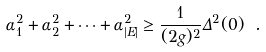<formula> <loc_0><loc_0><loc_500><loc_500>\alpha _ { 1 } ^ { 2 } + \alpha _ { 2 } ^ { 2 } + \dots + \alpha _ { | E | } ^ { 2 } \geq \frac { 1 } { ( 2 g ) ^ { 2 } } \Delta ^ { 2 } ( 0 ) \ .</formula> 